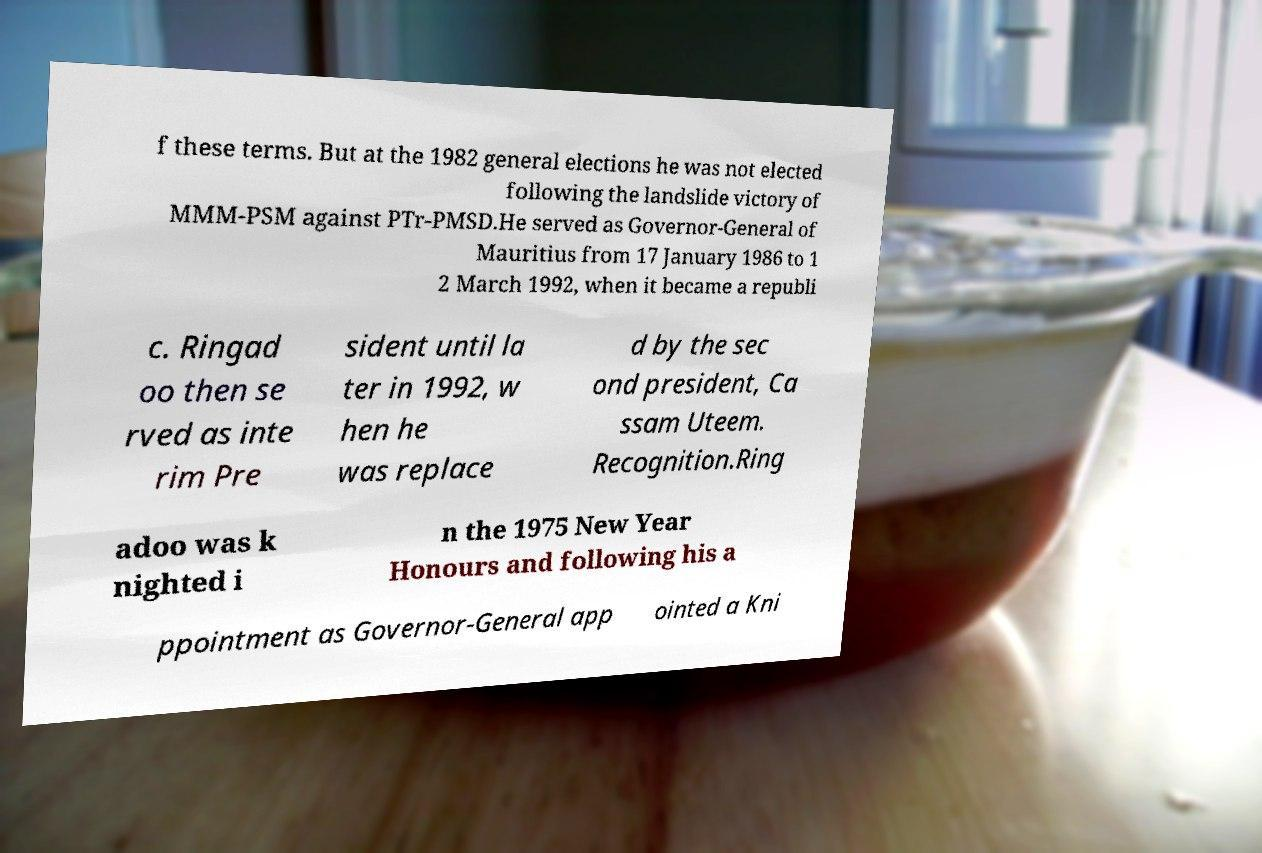What messages or text are displayed in this image? I need them in a readable, typed format. f these terms. But at the 1982 general elections he was not elected following the landslide victory of MMM-PSM against PTr-PMSD.He served as Governor-General of Mauritius from 17 January 1986 to 1 2 March 1992, when it became a republi c. Ringad oo then se rved as inte rim Pre sident until la ter in 1992, w hen he was replace d by the sec ond president, Ca ssam Uteem. Recognition.Ring adoo was k nighted i n the 1975 New Year Honours and following his a ppointment as Governor-General app ointed a Kni 